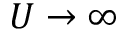Convert formula to latex. <formula><loc_0><loc_0><loc_500><loc_500>U \rightarrow \infty</formula> 